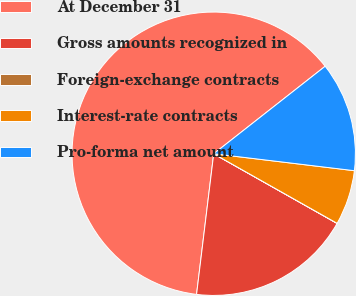<chart> <loc_0><loc_0><loc_500><loc_500><pie_chart><fcel>At December 31<fcel>Gross amounts recognized in<fcel>Foreign-exchange contracts<fcel>Interest-rate contracts<fcel>Pro-forma net amount<nl><fcel>62.47%<fcel>18.75%<fcel>0.01%<fcel>6.26%<fcel>12.5%<nl></chart> 